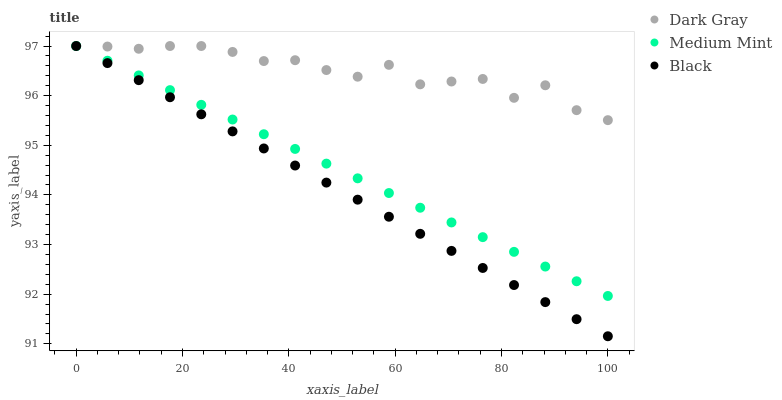Does Black have the minimum area under the curve?
Answer yes or no. Yes. Does Dark Gray have the maximum area under the curve?
Answer yes or no. Yes. Does Medium Mint have the minimum area under the curve?
Answer yes or no. No. Does Medium Mint have the maximum area under the curve?
Answer yes or no. No. Is Medium Mint the smoothest?
Answer yes or no. Yes. Is Dark Gray the roughest?
Answer yes or no. Yes. Is Black the smoothest?
Answer yes or no. No. Is Black the roughest?
Answer yes or no. No. Does Black have the lowest value?
Answer yes or no. Yes. Does Medium Mint have the lowest value?
Answer yes or no. No. Does Black have the highest value?
Answer yes or no. Yes. Does Medium Mint intersect Dark Gray?
Answer yes or no. Yes. Is Medium Mint less than Dark Gray?
Answer yes or no. No. Is Medium Mint greater than Dark Gray?
Answer yes or no. No. 